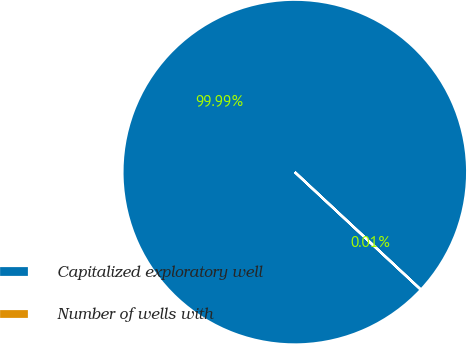Convert chart to OTSL. <chart><loc_0><loc_0><loc_500><loc_500><pie_chart><fcel>Capitalized exploratory well<fcel>Number of wells with<nl><fcel>99.99%<fcel>0.01%<nl></chart> 